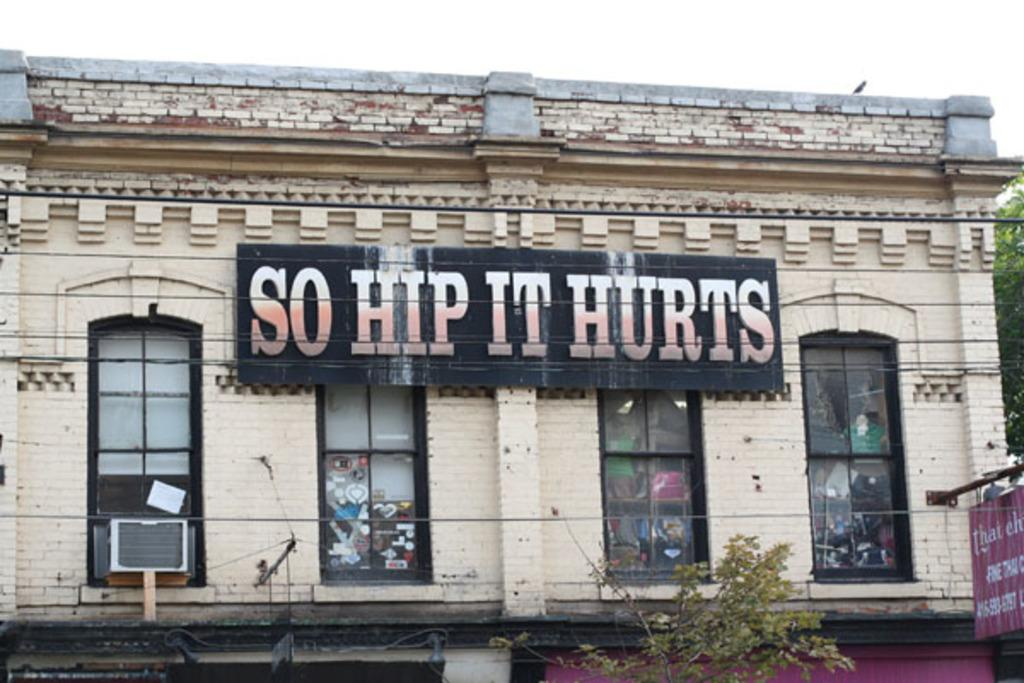What type of structure is depicted in the image? There is a building with four windows in the image. What is on the wall of the building? There is a hoarding on the wall of the building. What can be seen at the bottom of the image? There is a plant at the bottom of the image. What is visible at the top of the image? The sky is visible at the top of the image. Can you tell me what type of dog is sitting on the seat in the image? There is no dog or seat present in the image. 